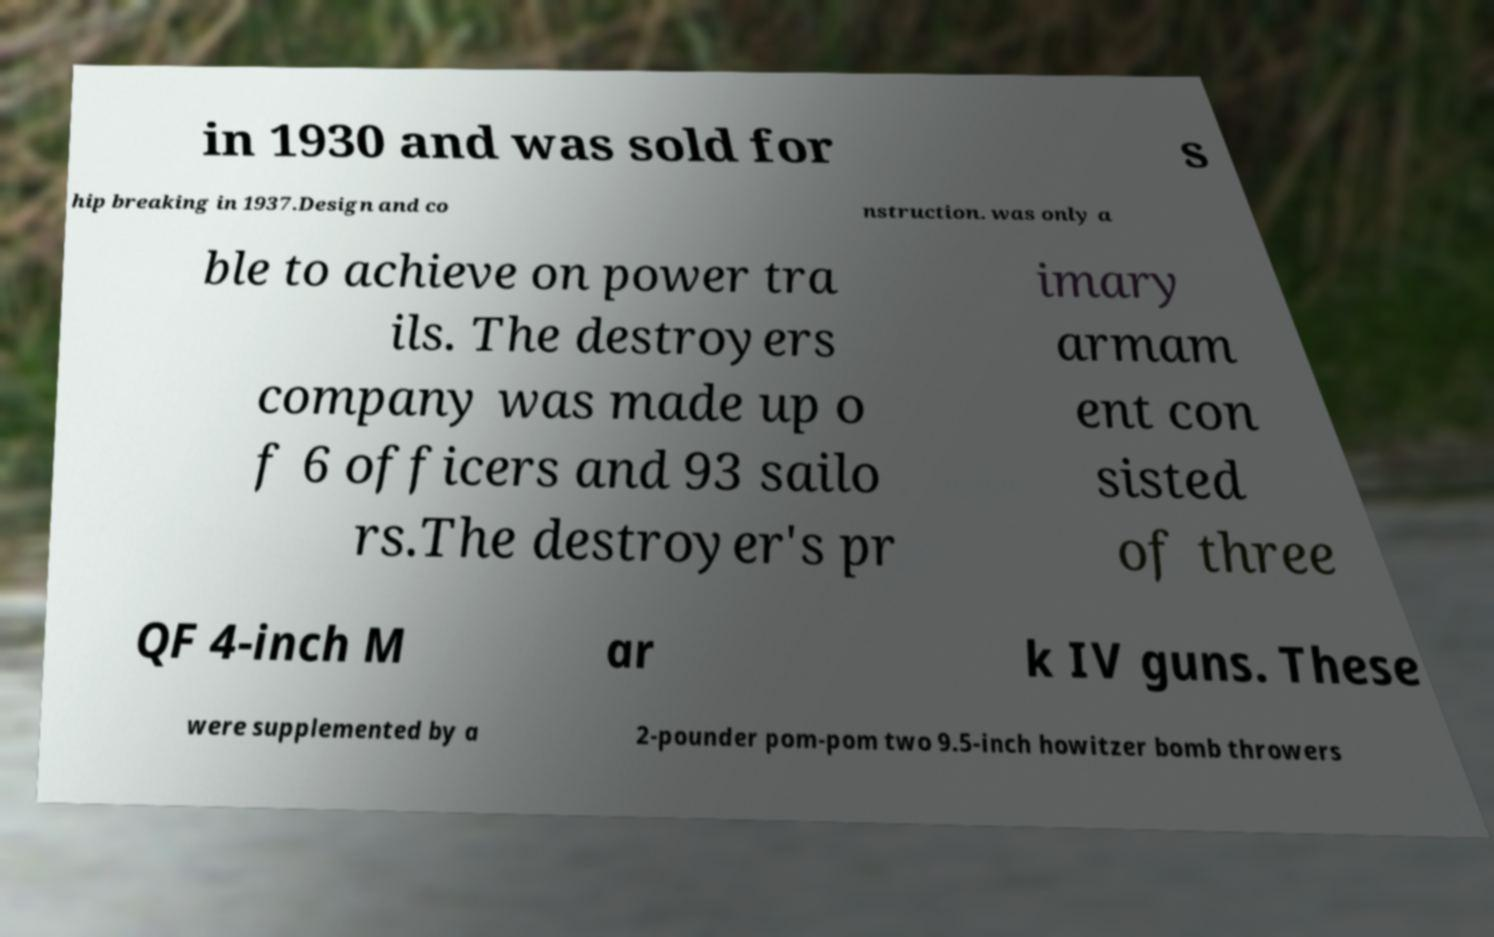Please read and relay the text visible in this image. What does it say? in 1930 and was sold for s hip breaking in 1937.Design and co nstruction. was only a ble to achieve on power tra ils. The destroyers company was made up o f 6 officers and 93 sailo rs.The destroyer's pr imary armam ent con sisted of three QF 4-inch M ar k IV guns. These were supplemented by a 2-pounder pom-pom two 9.5-inch howitzer bomb throwers 